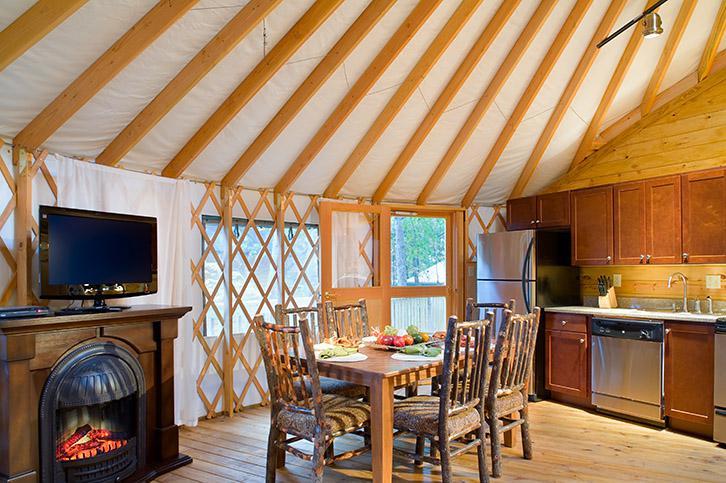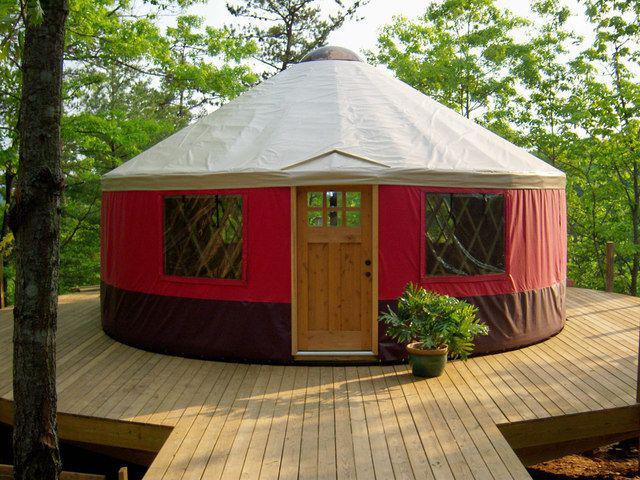The first image is the image on the left, the second image is the image on the right. Considering the images on both sides, is "At least one image you can see inside of the house." valid? Answer yes or no. Yes. 